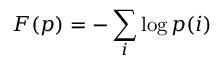<formula> <loc_0><loc_0><loc_500><loc_500>F ( p ) = - \sum _ { i } \log p ( i )</formula> 